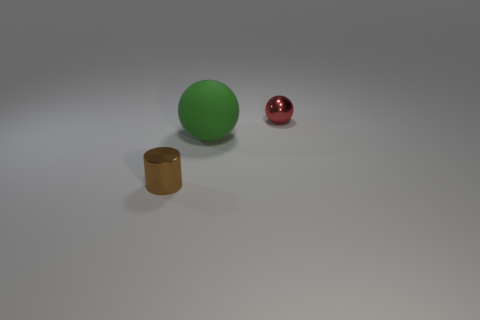What number of red shiny spheres are on the left side of the sphere on the left side of the small shiny object that is to the right of the tiny brown shiny cylinder?
Keep it short and to the point. 0. Is the size of the object that is on the right side of the large rubber thing the same as the object that is left of the large sphere?
Offer a very short reply. Yes. What material is the small object that is on the left side of the sphere on the right side of the matte ball?
Give a very brief answer. Metal. What number of things are either metal objects on the left side of the tiny red ball or big green matte spheres?
Offer a very short reply. 2. Is the number of large rubber balls to the right of the tiny cylinder the same as the number of small brown objects behind the green ball?
Provide a succinct answer. No. The tiny thing that is on the left side of the small shiny thing right of the metal object in front of the tiny metal sphere is made of what material?
Your response must be concise. Metal. What size is the object that is both in front of the red object and to the right of the tiny cylinder?
Offer a very short reply. Large. Do the red object and the large green matte thing have the same shape?
Your answer should be very brief. Yes. What is the shape of the brown thing that is made of the same material as the red object?
Give a very brief answer. Cylinder. How many large objects are either red metallic balls or gray shiny cylinders?
Offer a terse response. 0. 